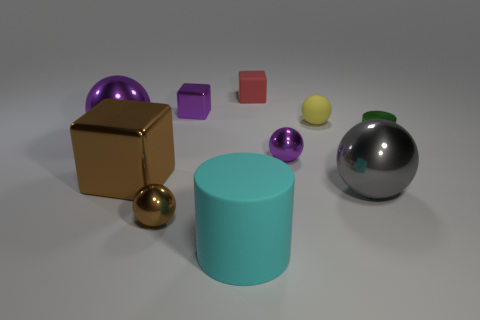What number of shiny spheres are behind the purple shiny sphere behind the green object?
Your answer should be very brief. 0. There is a purple metal object that is both in front of the tiny yellow rubber object and right of the big metal cube; what is its size?
Your answer should be compact. Small. Are there more cyan matte objects than yellow matte blocks?
Ensure brevity in your answer.  Yes. Is there a small thing that has the same color as the large cube?
Your answer should be compact. Yes. There is a purple metallic sphere that is to the left of the red rubber object; does it have the same size as the tiny red cube?
Your answer should be compact. No. Are there fewer brown things than cubes?
Give a very brief answer. Yes. Is there a small red object that has the same material as the large cyan cylinder?
Make the answer very short. Yes. What shape is the tiny purple metallic thing that is left of the red block?
Offer a very short reply. Cube. Do the big metallic ball on the left side of the tiny rubber cube and the tiny metal block have the same color?
Your response must be concise. Yes. Are there fewer brown metal cubes behind the matte block than tiny green cylinders?
Offer a terse response. Yes. 